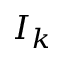Convert formula to latex. <formula><loc_0><loc_0><loc_500><loc_500>I _ { k }</formula> 